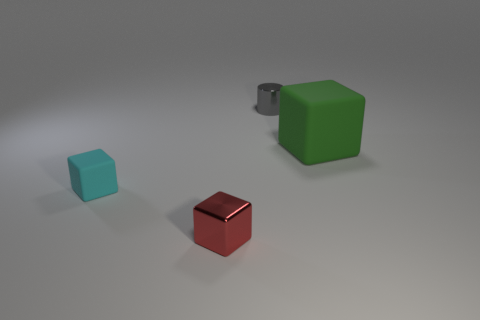Add 1 metallic cylinders. How many objects exist? 5 Subtract all cubes. How many objects are left? 1 Subtract 0 red cylinders. How many objects are left? 4 Subtract all small cyan rubber objects. Subtract all blocks. How many objects are left? 0 Add 1 green rubber blocks. How many green rubber blocks are left? 2 Add 1 tiny purple cylinders. How many tiny purple cylinders exist? 1 